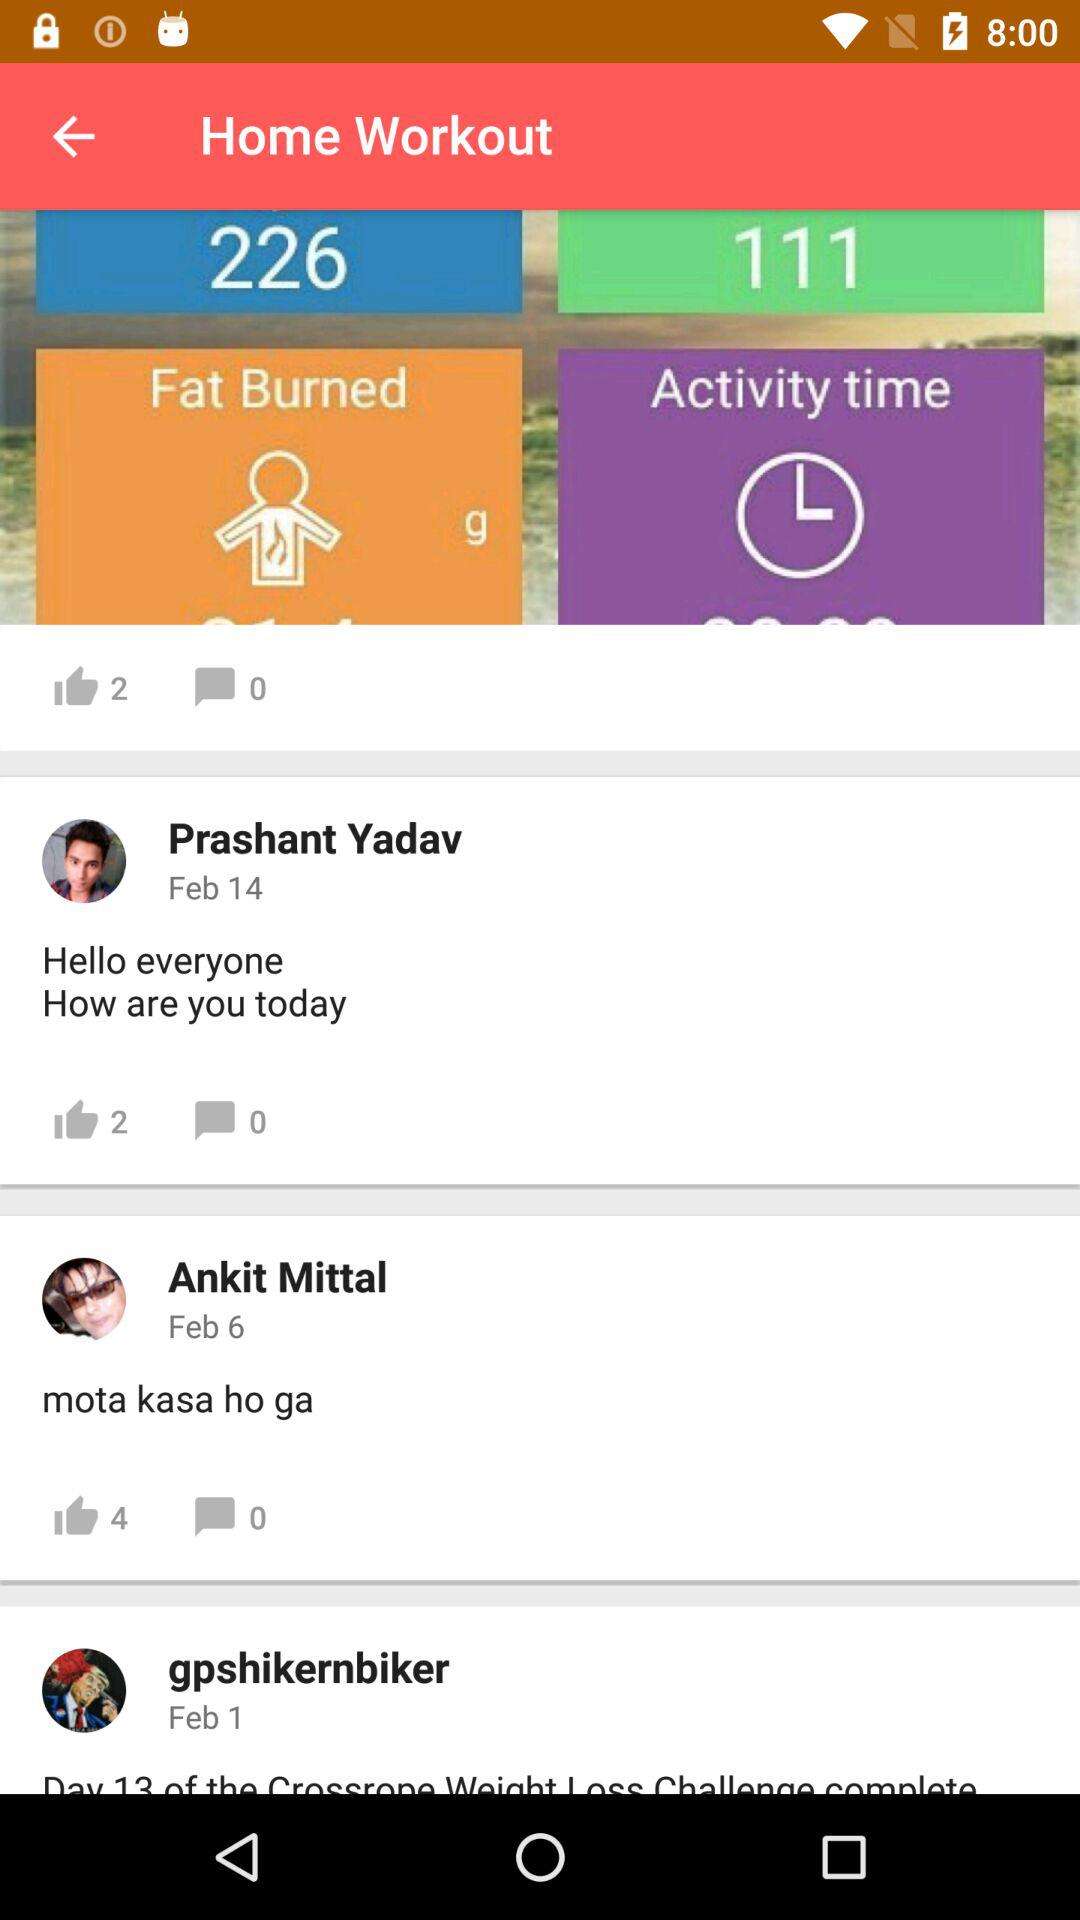How many more likes does the message with the text 'Day 13 of the Crossrope Weight Loss Challenge complete' have than the message with the text 'Hello everyone How are you today'?
Answer the question using a single word or phrase. 2 